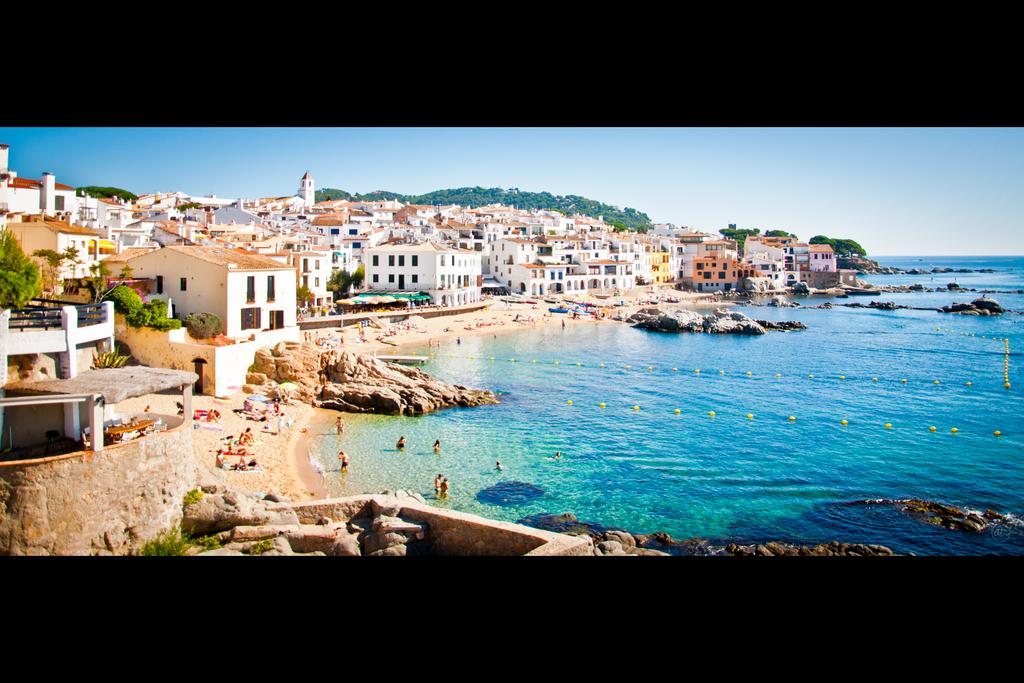How many people are in the image? There is a group of people in the image. What type of natural elements can be seen in the image? There are rocks, water, and trees in the image. What type of man-made structures are present in the image? There are buildings and houses in the image. What is visible in the background of the image? The sky is visible in the background of the image. What type of advertisement can be seen on the hand of one of the people in the image? There is no advertisement visible on anyone's hand in the image. What type of flag is being waved by the group of people in the image? There is no flag present in the image. 